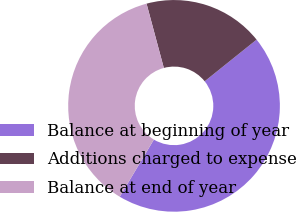Convert chart to OTSL. <chart><loc_0><loc_0><loc_500><loc_500><pie_chart><fcel>Balance at beginning of year<fcel>Additions charged to expense<fcel>Balance at end of year<nl><fcel>44.33%<fcel>18.42%<fcel>37.25%<nl></chart> 